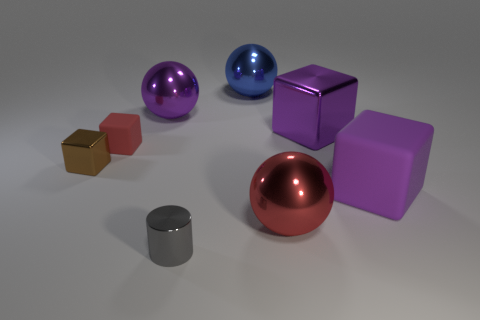What is the material of the sphere that is the same color as the tiny rubber cube?
Offer a very short reply. Metal. There is a purple metal thing that is the same shape as the tiny red object; what size is it?
Ensure brevity in your answer.  Large. Is the big metallic block the same color as the big matte cube?
Provide a succinct answer. Yes. What is the color of the block that is to the right of the red block and in front of the red rubber object?
Keep it short and to the point. Purple. Does the red object that is behind the brown block have the same size as the cylinder?
Give a very brief answer. Yes. Is there anything else that is the same shape as the gray thing?
Offer a very short reply. No. Are the big purple sphere and the red thing on the left side of the gray shiny cylinder made of the same material?
Your answer should be compact. No. How many purple things are either big balls or big metal objects?
Offer a very short reply. 2. Are any purple cylinders visible?
Provide a succinct answer. No. Are there any small cylinders to the right of the purple shiny object in front of the ball on the left side of the gray metallic thing?
Provide a succinct answer. No. 